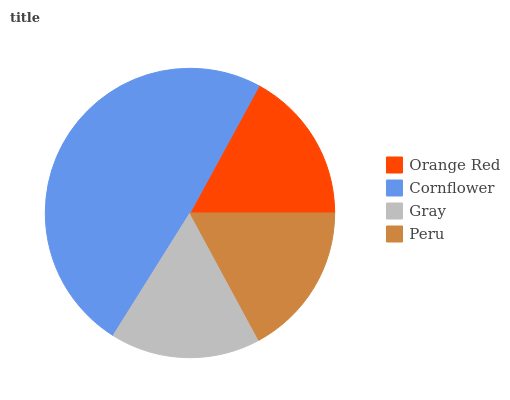Is Gray the minimum?
Answer yes or no. Yes. Is Cornflower the maximum?
Answer yes or no. Yes. Is Cornflower the minimum?
Answer yes or no. No. Is Gray the maximum?
Answer yes or no. No. Is Cornflower greater than Gray?
Answer yes or no. Yes. Is Gray less than Cornflower?
Answer yes or no. Yes. Is Gray greater than Cornflower?
Answer yes or no. No. Is Cornflower less than Gray?
Answer yes or no. No. Is Peru the high median?
Answer yes or no. Yes. Is Orange Red the low median?
Answer yes or no. Yes. Is Cornflower the high median?
Answer yes or no. No. Is Gray the low median?
Answer yes or no. No. 